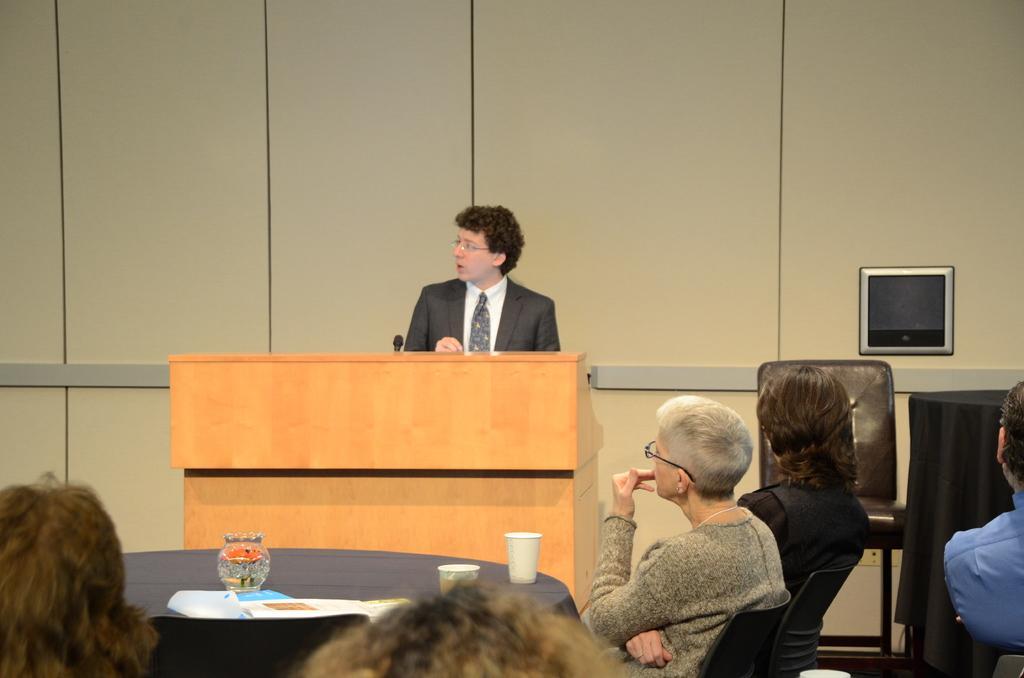In one or two sentences, can you explain what this image depicts? In this image there are people sitting on chairs, in front of them there is a table, on that table there are cups and a man standing near a podium. 